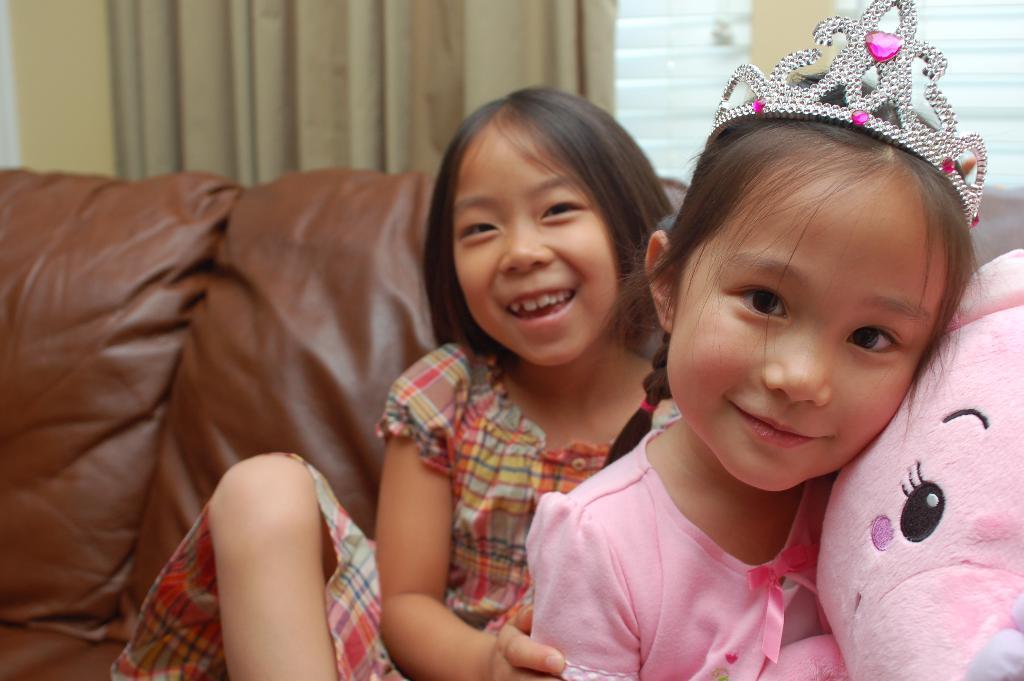Describe this image in one or two sentences. There are girls smiling and she wore crown, beside her we can see a doll. We can see sofa. In the background we can see wall, curtain and window. 